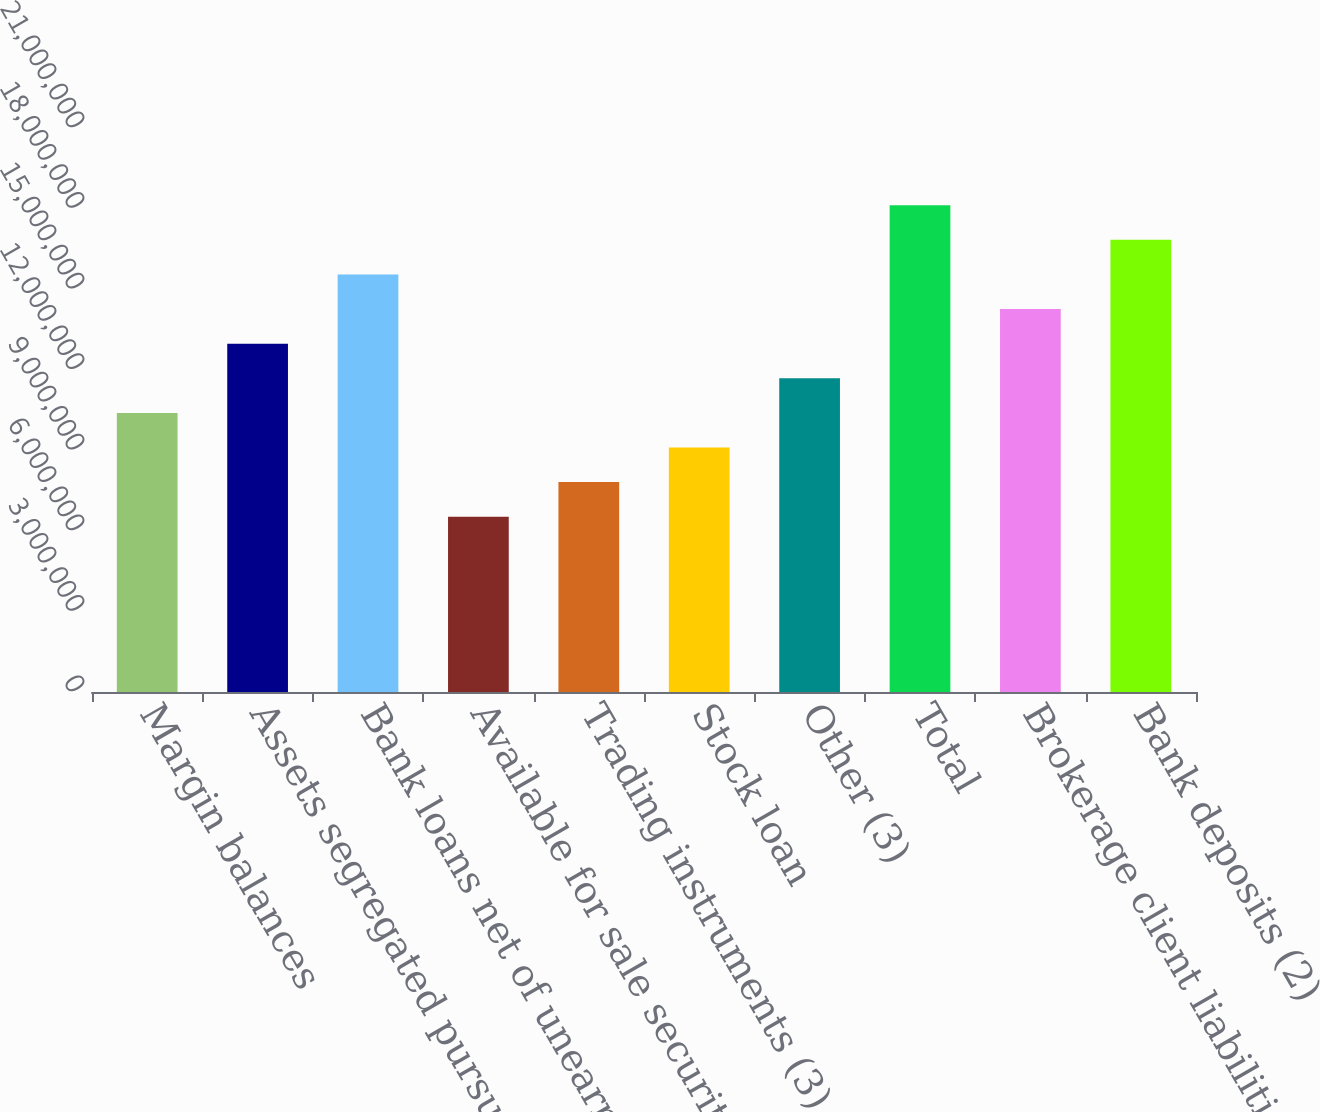<chart> <loc_0><loc_0><loc_500><loc_500><bar_chart><fcel>Margin balances<fcel>Assets segregated pursuant to<fcel>Bank loans net of unearned<fcel>Available for sale securities<fcel>Trading instruments (3)<fcel>Stock loan<fcel>Other (3)<fcel>Total<fcel>Brokerage client liabilities<fcel>Bank deposits (2)<nl><fcel>1.03925e+07<fcel>1.29703e+07<fcel>1.55481e+07<fcel>6.52579e+06<fcel>7.81469e+06<fcel>9.10359e+06<fcel>1.16814e+07<fcel>1.81259e+07<fcel>1.42592e+07<fcel>1.6837e+07<nl></chart> 